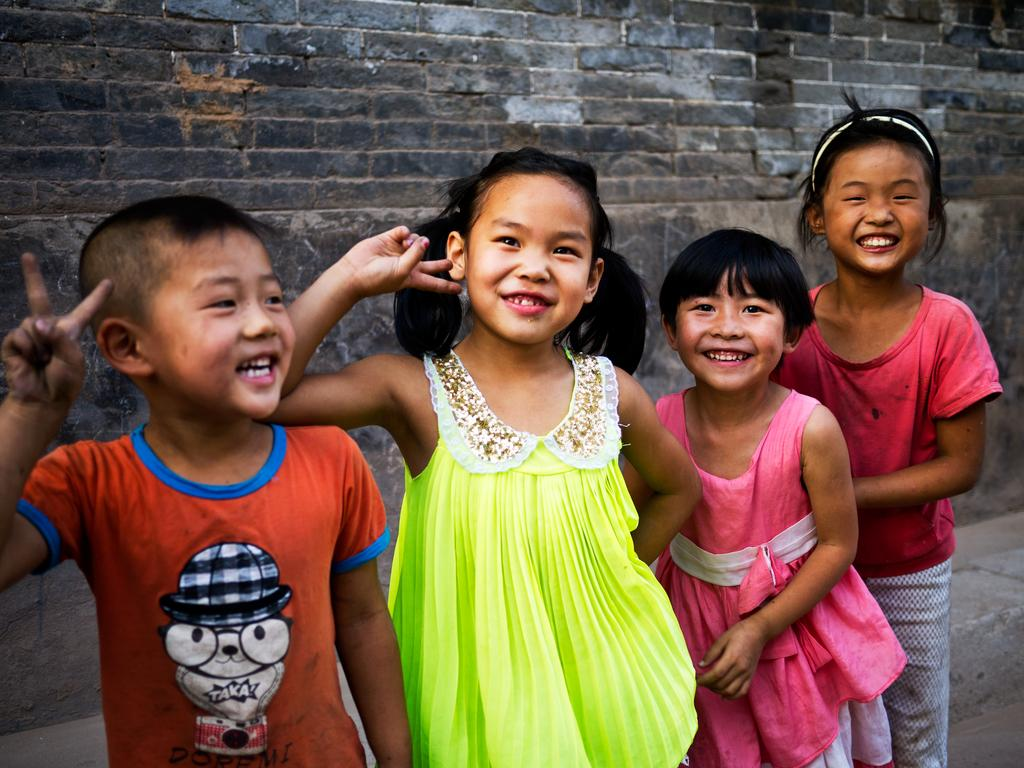What can be seen in the image? There are children standing in the image. What is the background of the image made of? There is a wall with bricks visible in the image. What type of cloth is being used to trick the children in the image? There is no cloth or trickery present in the image; it simply shows children standing near a brick wall. 